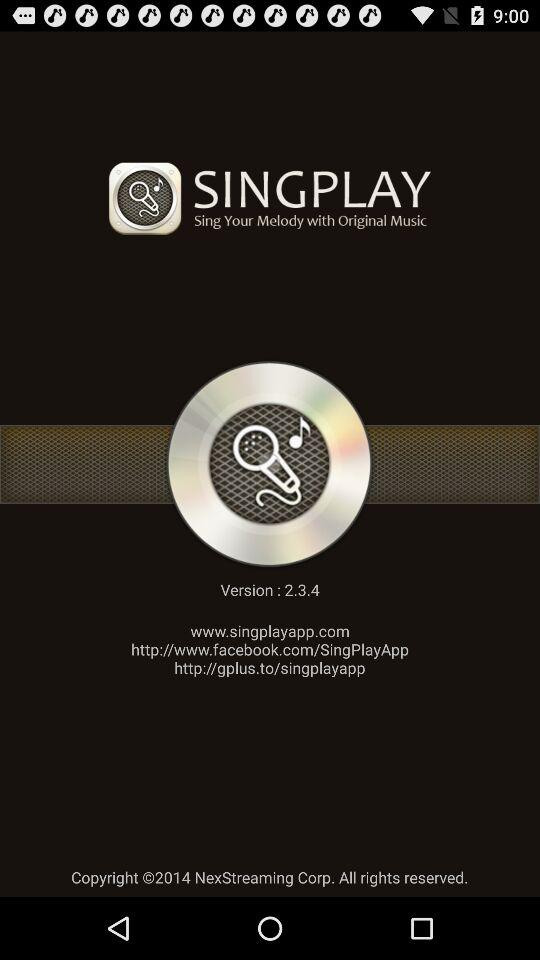What is the application name? The application name is "Singplay". 